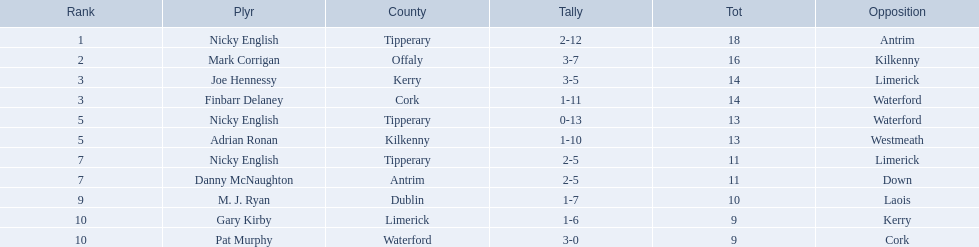Which of the following players were ranked in the bottom 5? Nicky English, Danny McNaughton, M. J. Ryan, Gary Kirby, Pat Murphy. Of these, whose tallies were not 2-5? M. J. Ryan, Gary Kirby, Pat Murphy. From the above three, which one scored more than 9 total points? M. J. Ryan. 